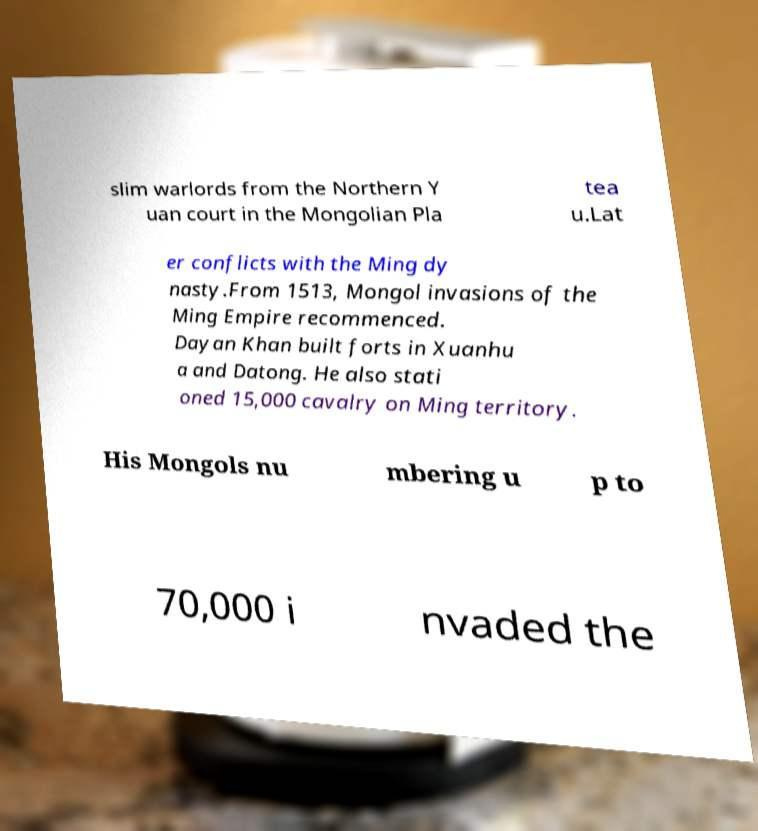Can you read and provide the text displayed in the image?This photo seems to have some interesting text. Can you extract and type it out for me? slim warlords from the Northern Y uan court in the Mongolian Pla tea u.Lat er conflicts with the Ming dy nasty.From 1513, Mongol invasions of the Ming Empire recommenced. Dayan Khan built forts in Xuanhu a and Datong. He also stati oned 15,000 cavalry on Ming territory. His Mongols nu mbering u p to 70,000 i nvaded the 